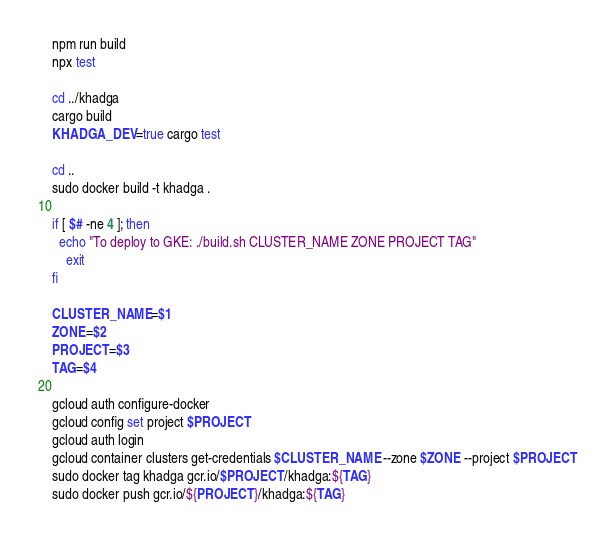<code> <loc_0><loc_0><loc_500><loc_500><_Bash_>npm run build
npx test

cd ../khadga
cargo build
KHADGA_DEV=true cargo test

cd ..
sudo docker build -t khadga .

if [ $# -ne 4 ]; then
  echo "To deploy to GKE: ./build.sh CLUSTER_NAME ZONE PROJECT TAG"
	exit
fi

CLUSTER_NAME=$1
ZONE=$2
PROJECT=$3
TAG=$4

gcloud auth configure-docker
gcloud config set project $PROJECT
gcloud auth login
gcloud container clusters get-credentials $CLUSTER_NAME --zone $ZONE --project $PROJECT
sudo docker tag khadga gcr.io/$PROJECT/khadga:${TAG}
sudo docker push gcr.io/${PROJECT}/khadga:${TAG}</code> 